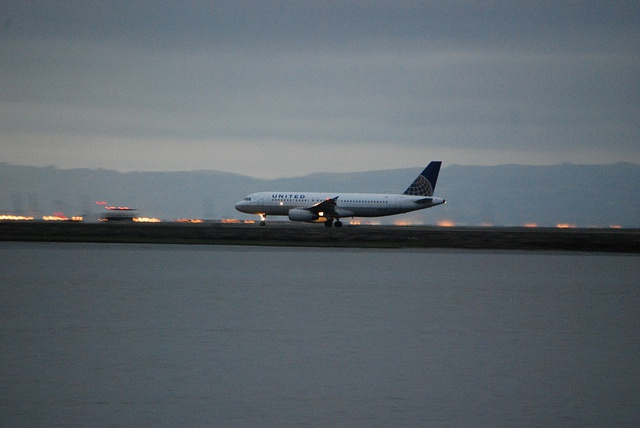Describe the objects in this image and their specific colors. I can see a airplane in gray, black, and darkgray tones in this image. 